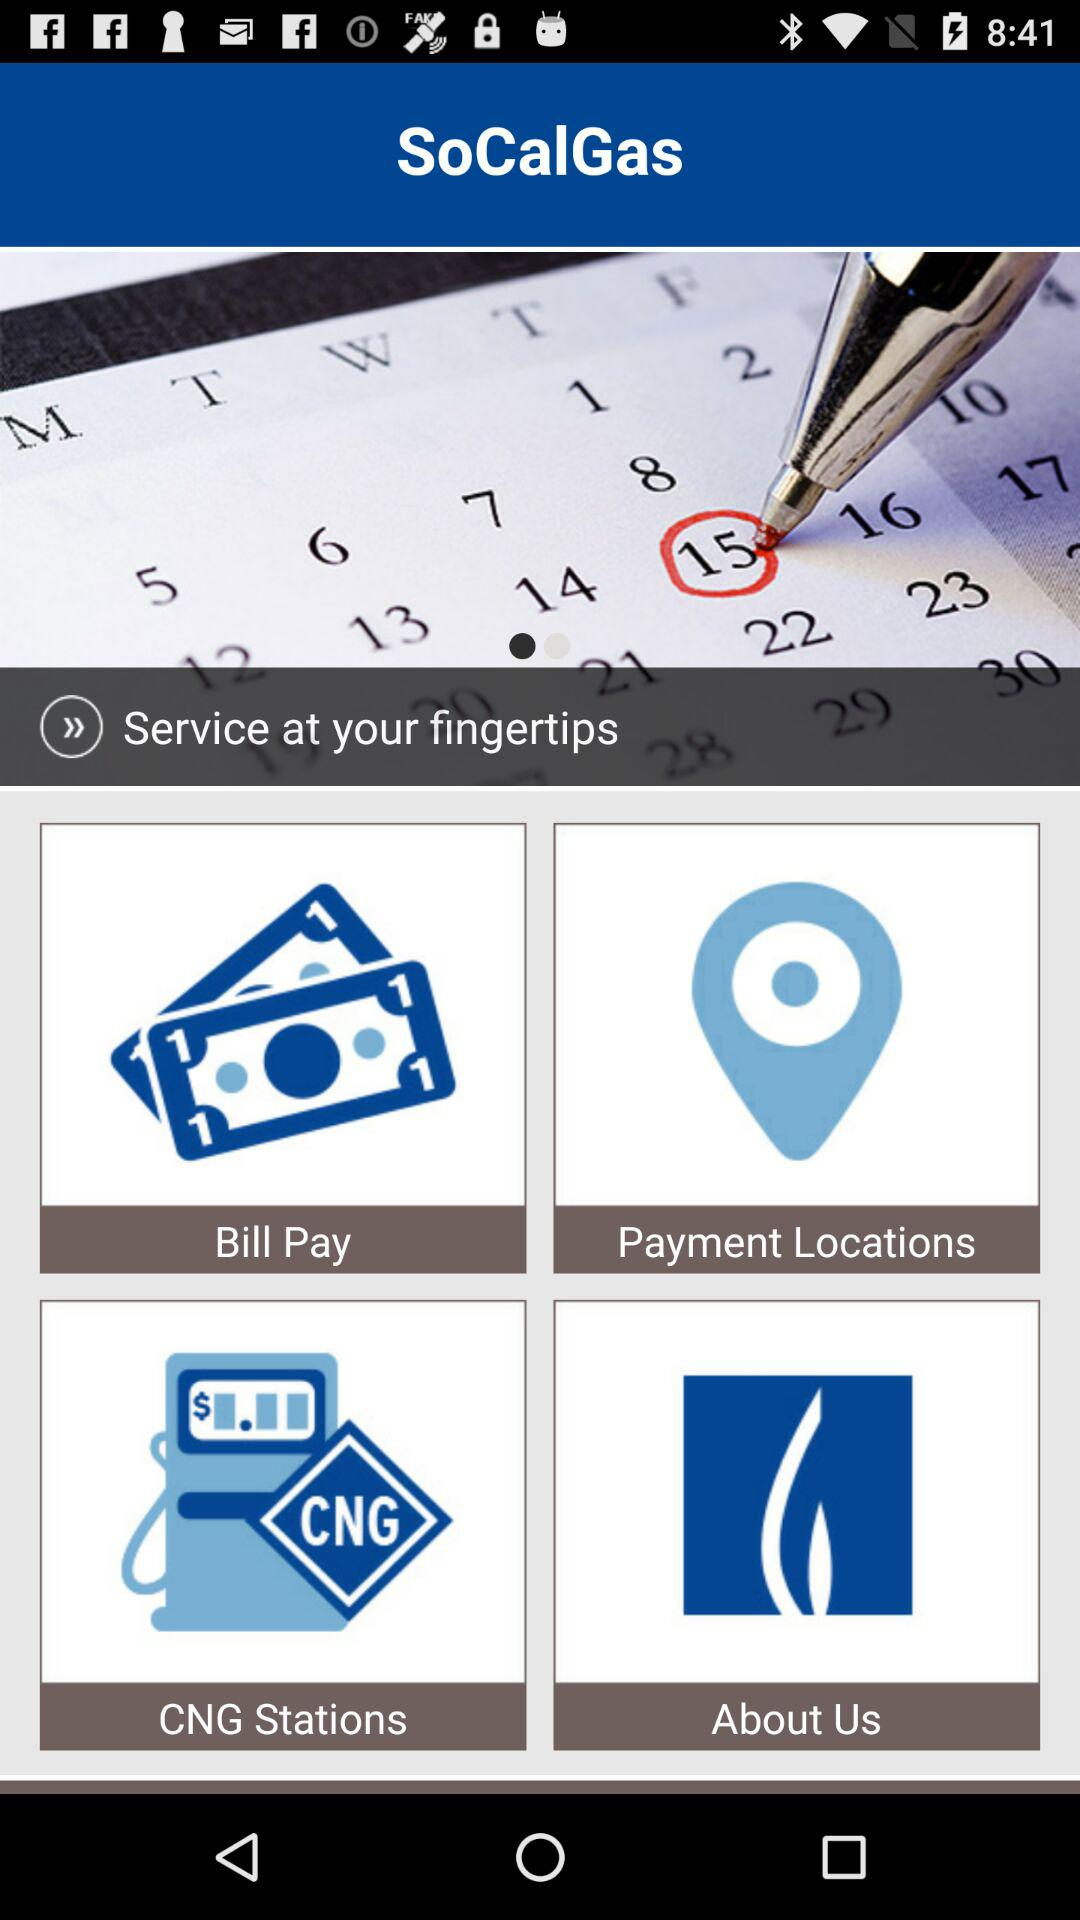What is the highlighted date? The highlighted date is 15. 